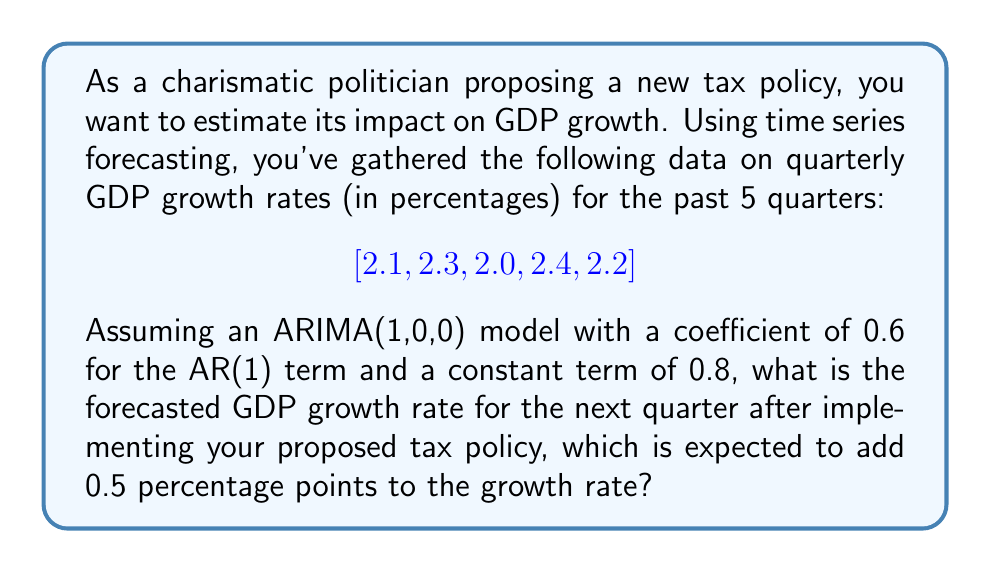Provide a solution to this math problem. To solve this problem, we'll use the ARIMA(1,0,0) model, also known as the AR(1) model. The formula for this model is:

$$Y_t = c + \phi Y_{t-1} + \epsilon_t$$

Where:
- $Y_t$ is the forecasted value at time t
- $c$ is the constant term (0.8 in this case)
- $\phi$ is the coefficient for the AR(1) term (0.6 in this case)
- $Y_{t-1}$ is the previous observed value
- $\epsilon_t$ is the error term (which we assume to be 0 for forecasting)

Steps to forecast:

1. Identify the most recent GDP growth rate: 2.2%

2. Apply the AR(1) model:
   $$Y_t = 0.8 + 0.6 \times 2.2$$
   $$Y_t = 0.8 + 1.32 = 2.12$$

3. Add the expected impact of the tax policy:
   $$2.12 + 0.5 = 2.62$$

Therefore, the forecasted GDP growth rate for the next quarter after implementing the proposed tax policy is 2.62%.
Answer: 2.62% 